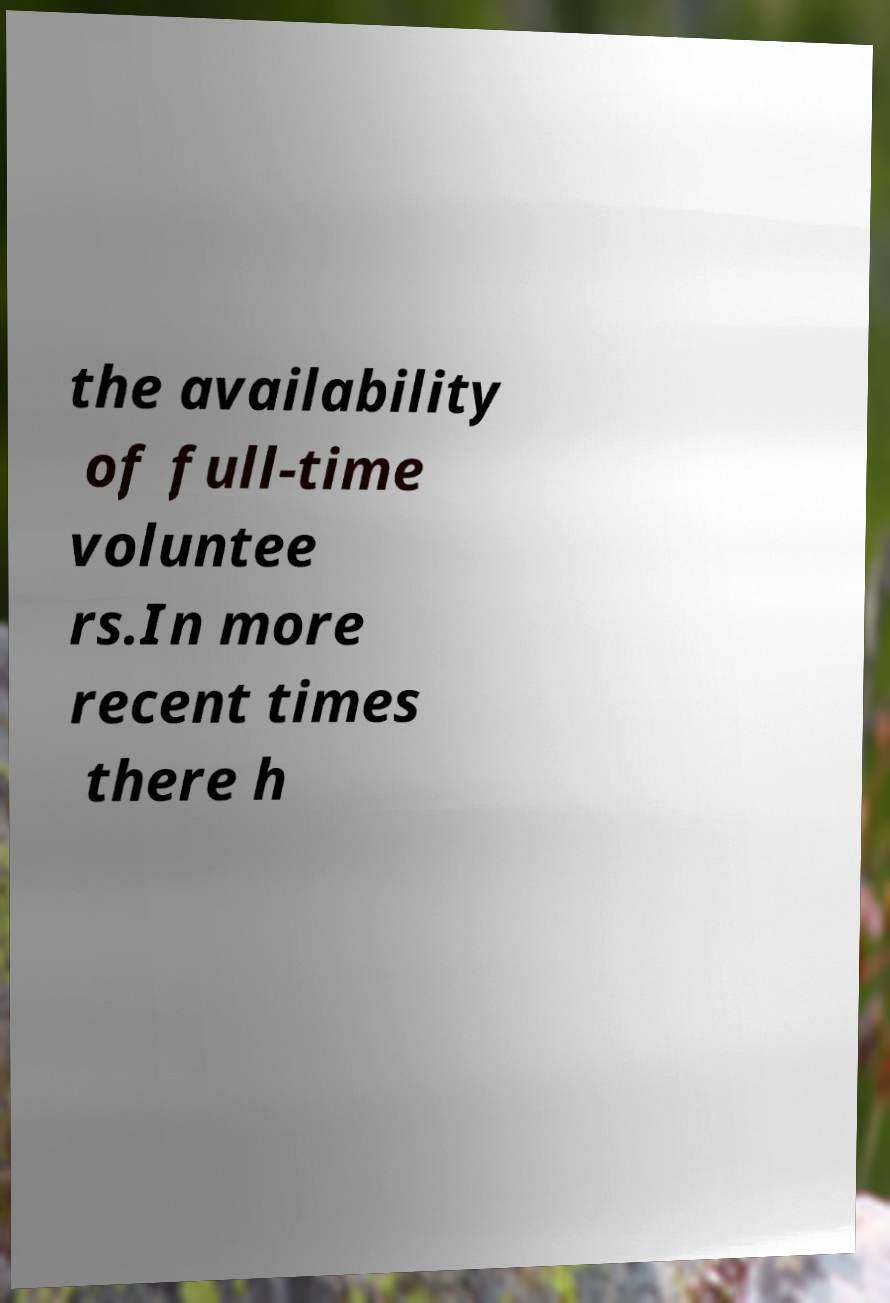Could you extract and type out the text from this image? the availability of full-time voluntee rs.In more recent times there h 